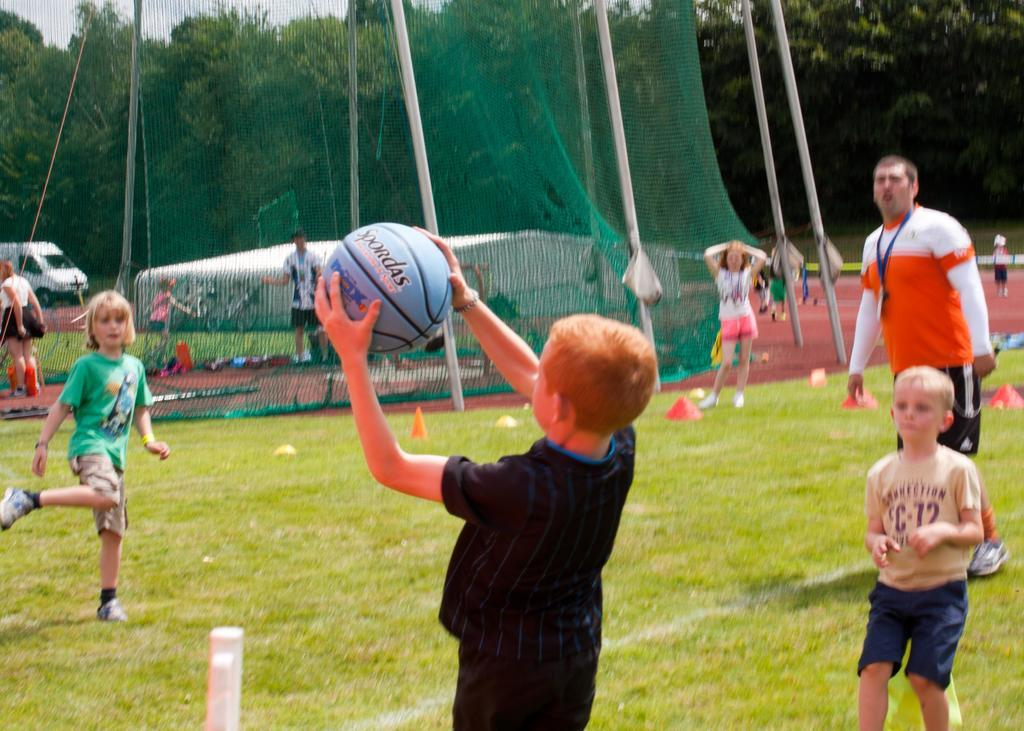What are the children in the image doing? The children are playing with a ball in the image. What can be seen in the background of the image? There is a net and trees in the background of the image. Is there any indication of a road in the image? Yes, there is a vehicle on the road in the image. What color is the vein visible in the image? There is no vein visible in the image. Which direction is the image facing, north or south? The image does not indicate a specific direction, such as north or south. 